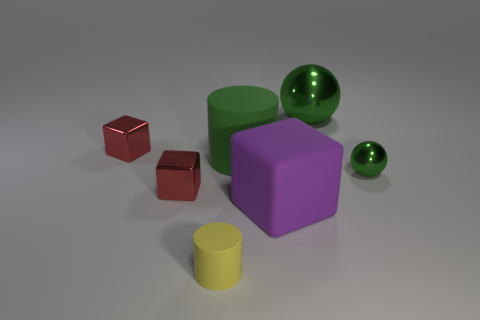Subtract all tiny blocks. How many blocks are left? 1 Add 1 big green shiny things. How many objects exist? 8 Subtract 0 green blocks. How many objects are left? 7 Subtract all spheres. How many objects are left? 5 Subtract all yellow objects. Subtract all tiny rubber cylinders. How many objects are left? 5 Add 6 metallic blocks. How many metallic blocks are left? 8 Add 1 small yellow cylinders. How many small yellow cylinders exist? 2 